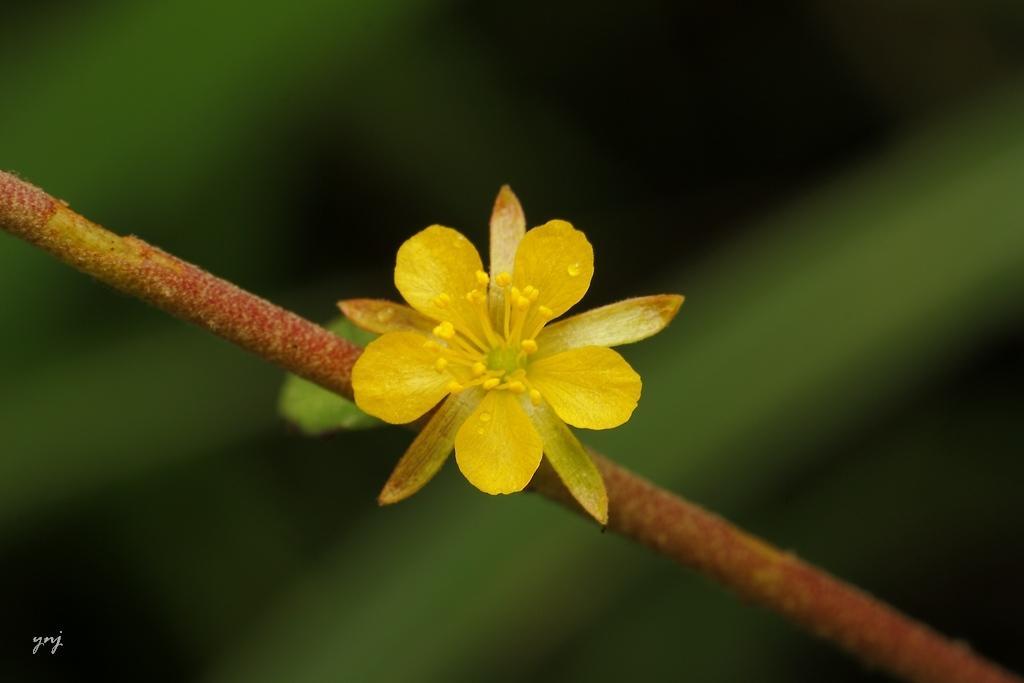How would you summarize this image in a sentence or two? In this image in the center there is one flower on a stem, and the background is blurred. At the bottom of the image there is text. 